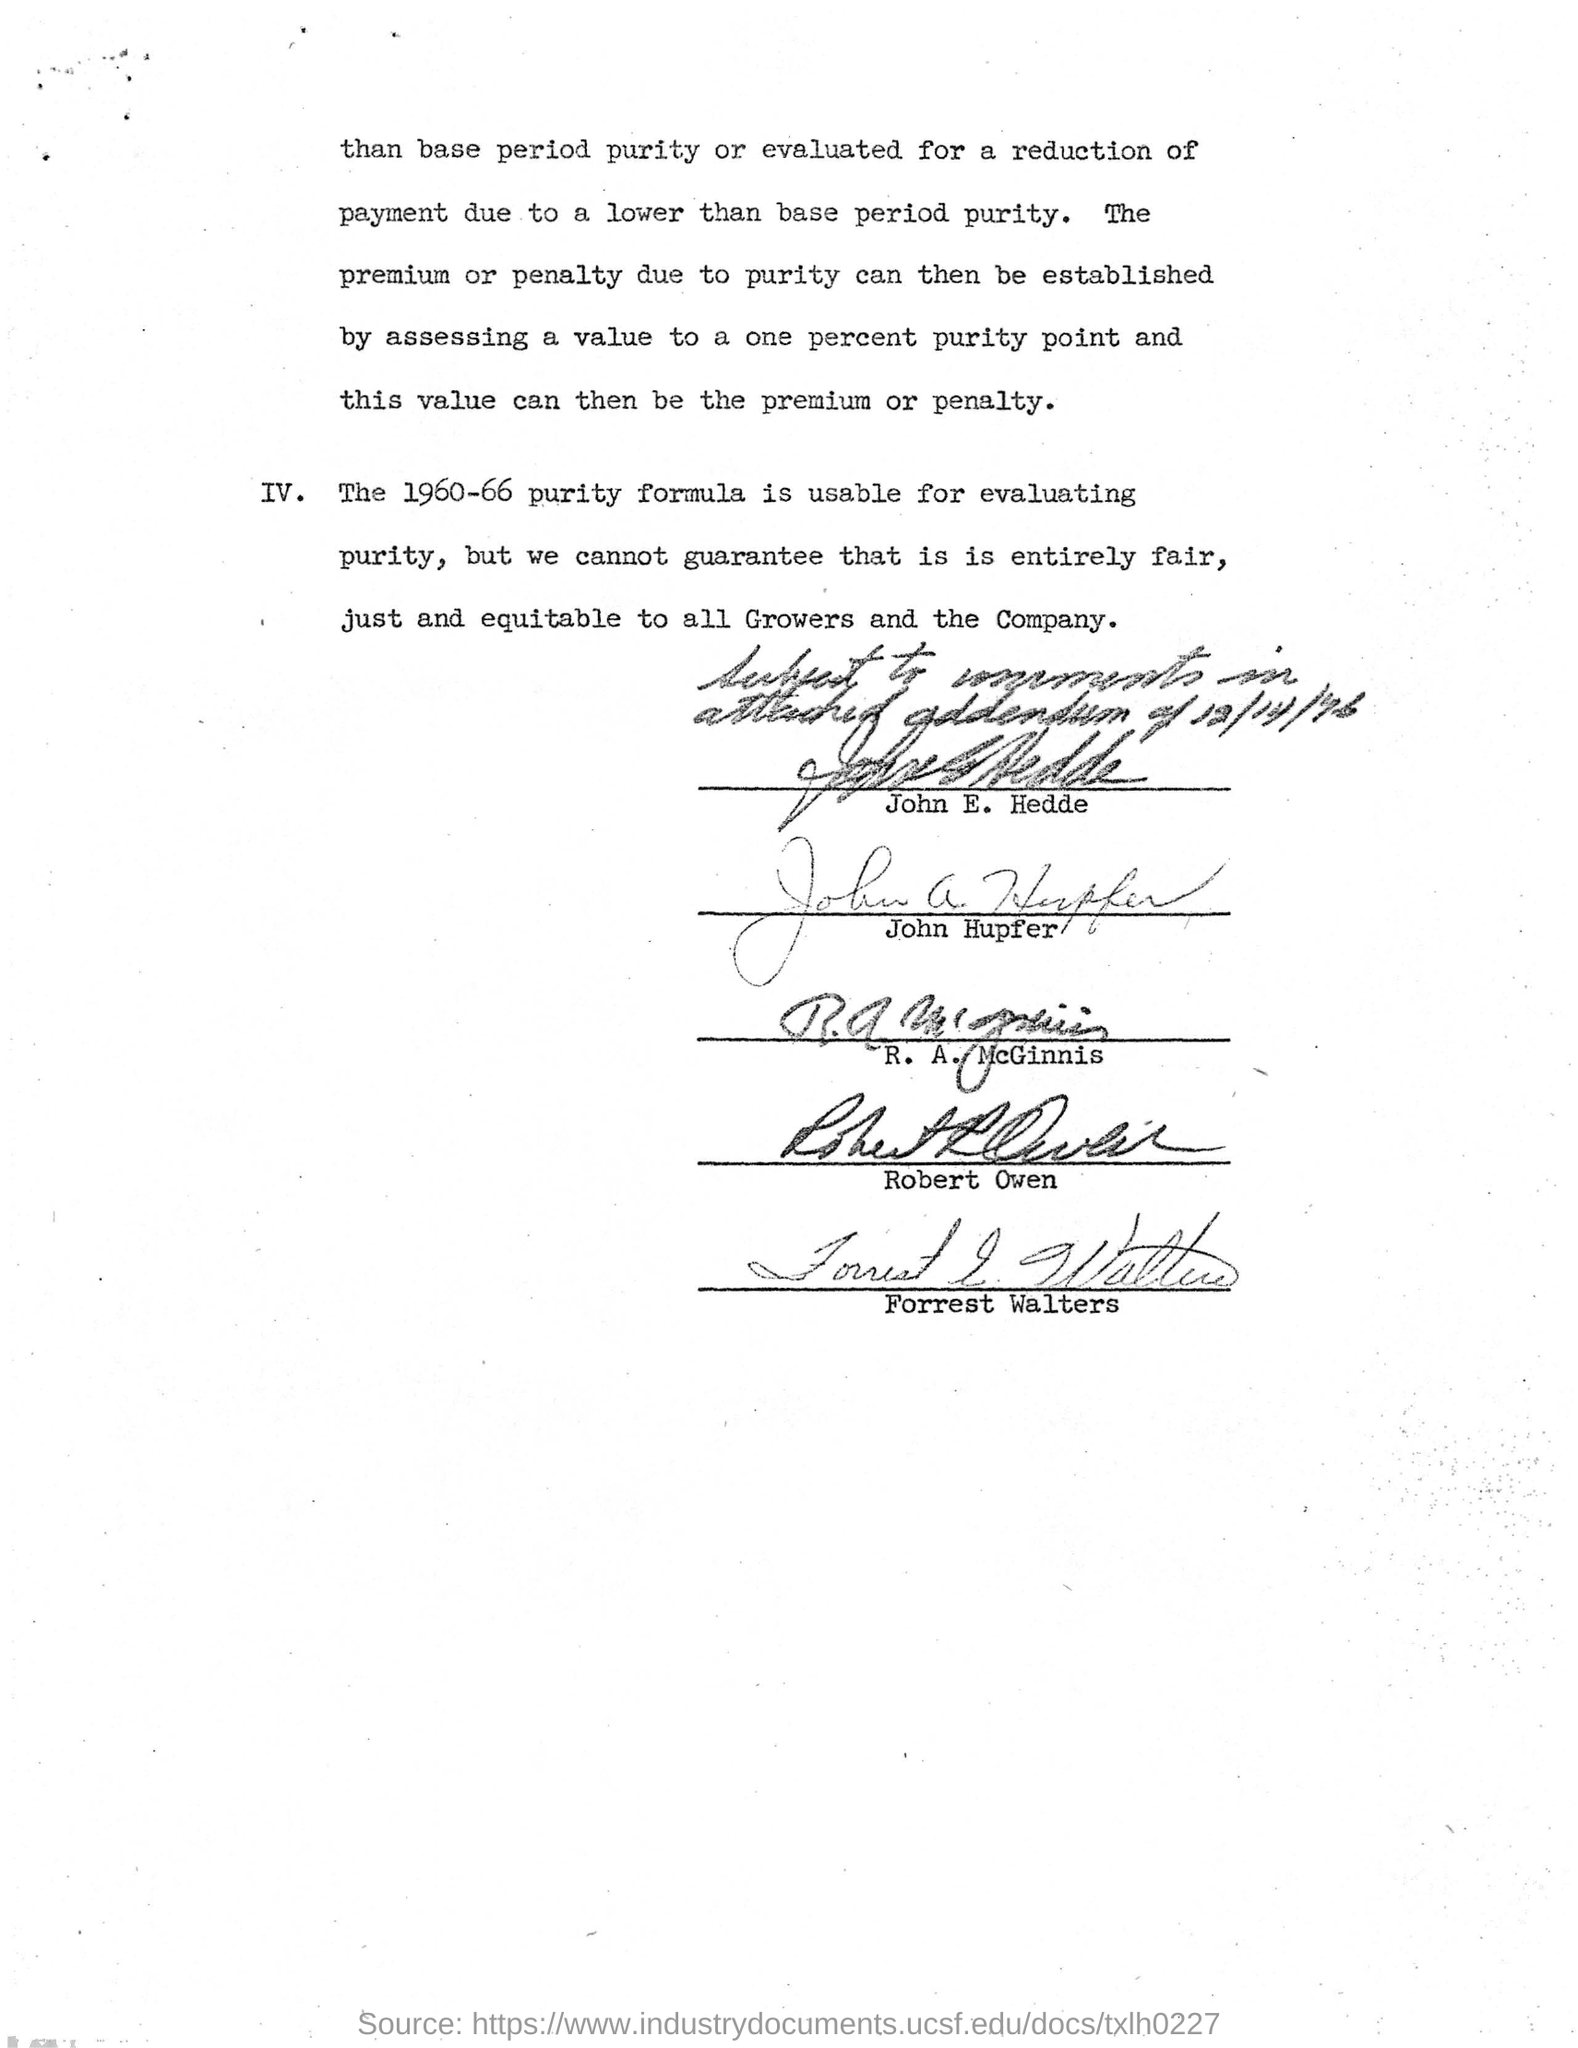Specify some key components in this picture. The document was signed by John E. Hedde at the beginning. The 1960-66 purity formula is suitable for determining the purity of a substance. 